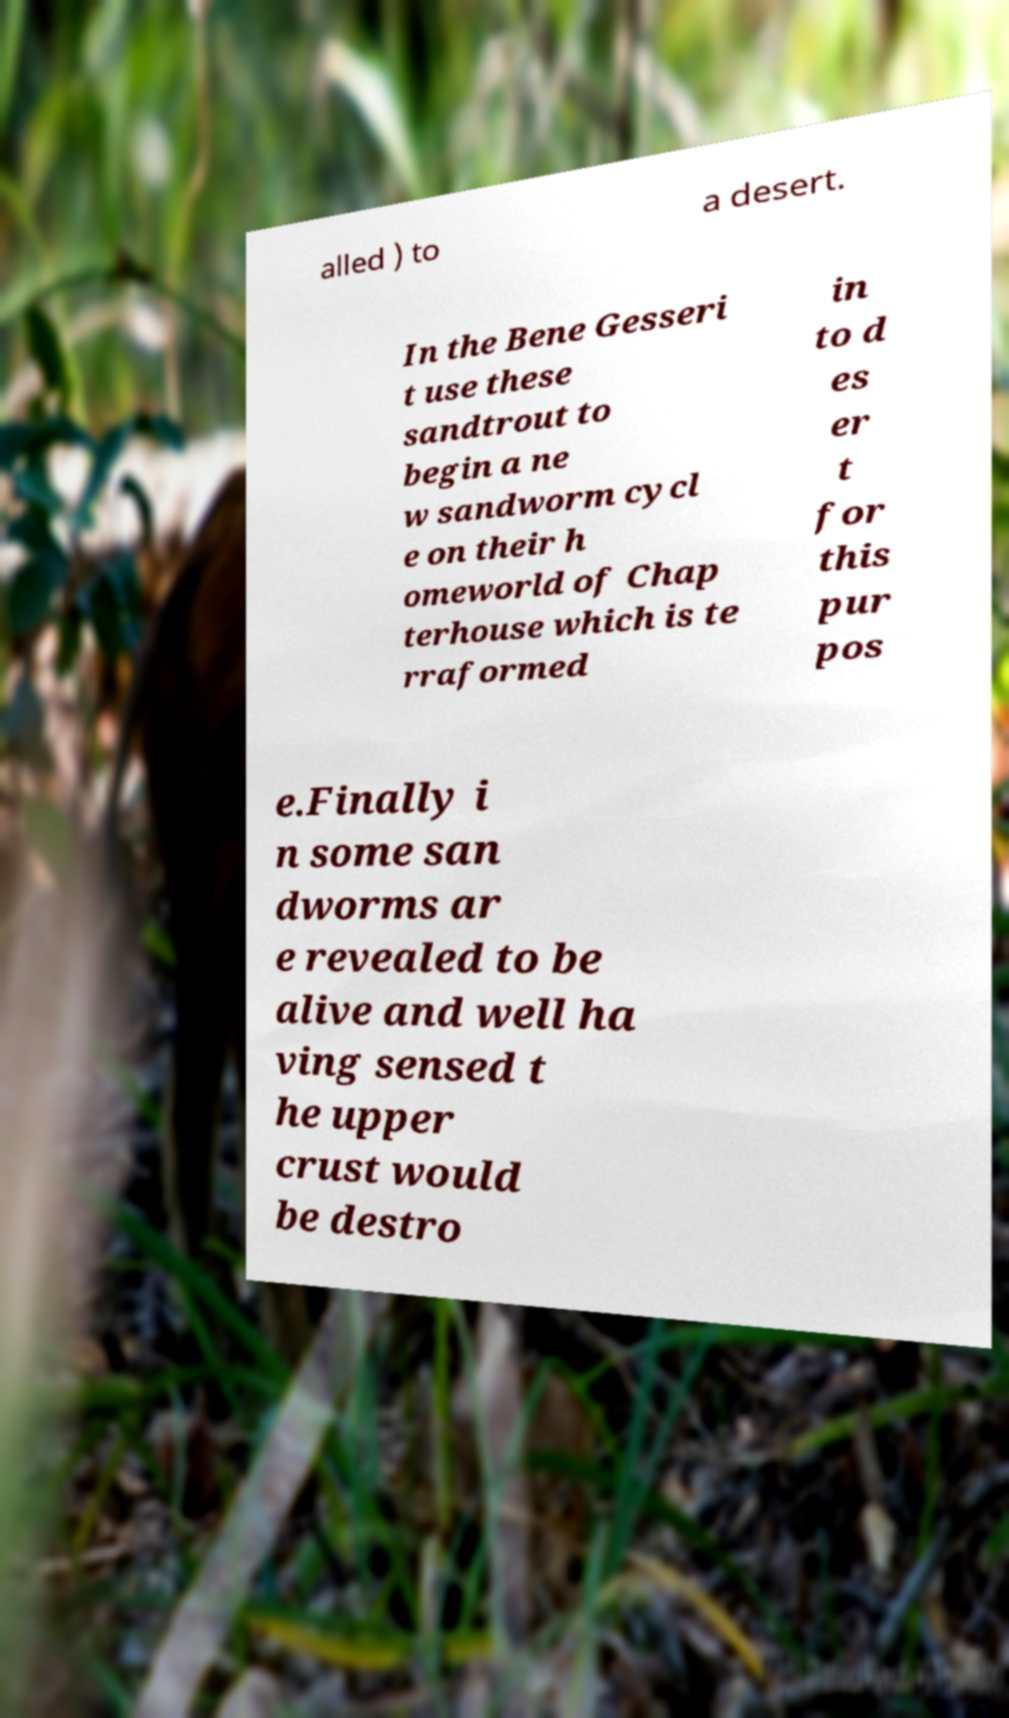Please read and relay the text visible in this image. What does it say? alled ) to a desert. In the Bene Gesseri t use these sandtrout to begin a ne w sandworm cycl e on their h omeworld of Chap terhouse which is te rraformed in to d es er t for this pur pos e.Finally i n some san dworms ar e revealed to be alive and well ha ving sensed t he upper crust would be destro 